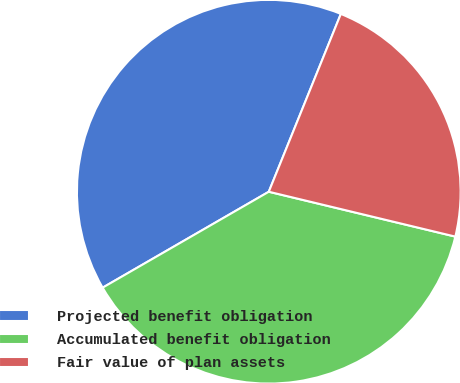<chart> <loc_0><loc_0><loc_500><loc_500><pie_chart><fcel>Projected benefit obligation<fcel>Accumulated benefit obligation<fcel>Fair value of plan assets<nl><fcel>39.46%<fcel>37.91%<fcel>22.63%<nl></chart> 